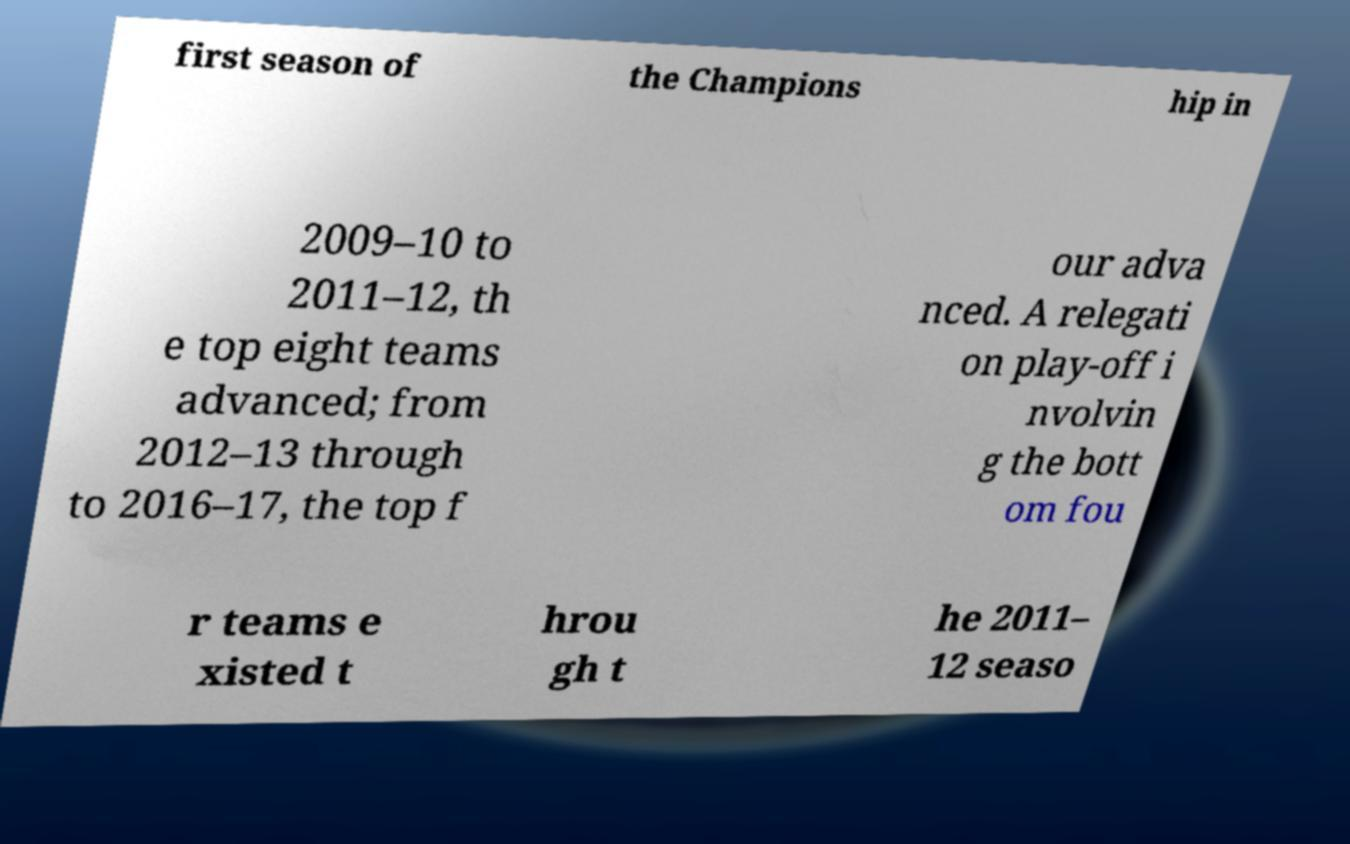There's text embedded in this image that I need extracted. Can you transcribe it verbatim? first season of the Champions hip in 2009–10 to 2011–12, th e top eight teams advanced; from 2012–13 through to 2016–17, the top f our adva nced. A relegati on play-off i nvolvin g the bott om fou r teams e xisted t hrou gh t he 2011– 12 seaso 